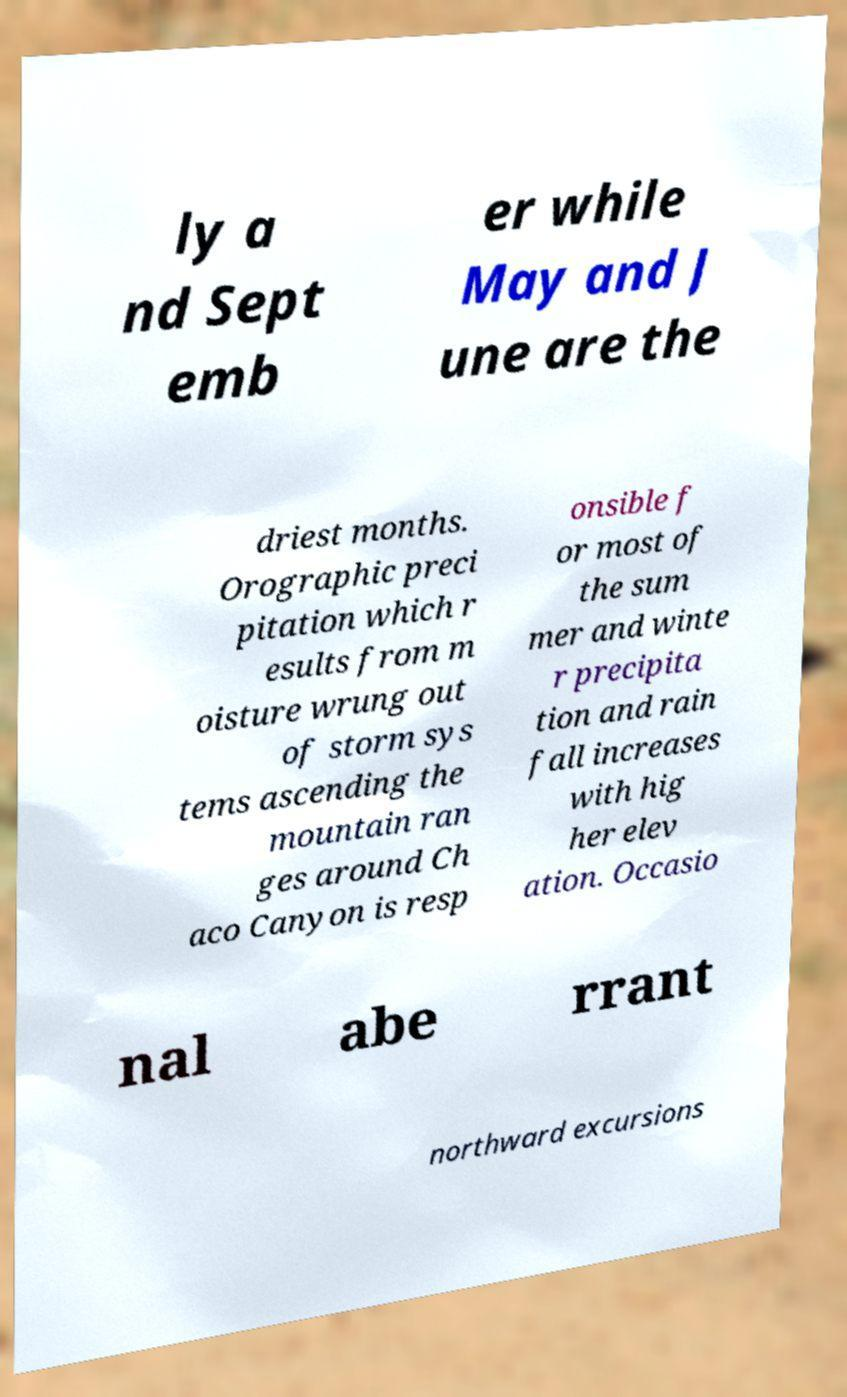There's text embedded in this image that I need extracted. Can you transcribe it verbatim? ly a nd Sept emb er while May and J une are the driest months. Orographic preci pitation which r esults from m oisture wrung out of storm sys tems ascending the mountain ran ges around Ch aco Canyon is resp onsible f or most of the sum mer and winte r precipita tion and rain fall increases with hig her elev ation. Occasio nal abe rrant northward excursions 